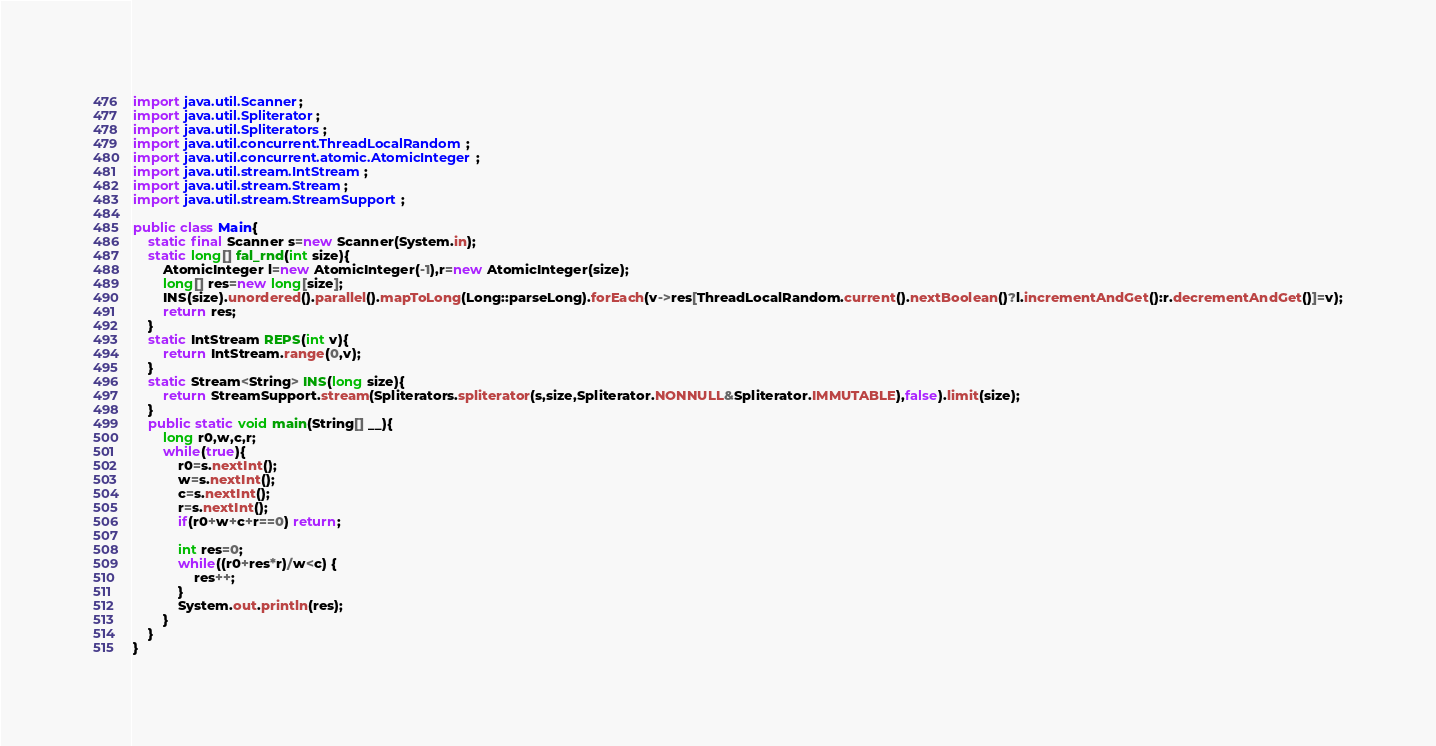Convert code to text. <code><loc_0><loc_0><loc_500><loc_500><_Java_>import java.util.Scanner;
import java.util.Spliterator;
import java.util.Spliterators;
import java.util.concurrent.ThreadLocalRandom;
import java.util.concurrent.atomic.AtomicInteger;
import java.util.stream.IntStream;
import java.util.stream.Stream;
import java.util.stream.StreamSupport;

public class Main{
	static final Scanner s=new Scanner(System.in);
	static long[] fal_rnd(int size){
		AtomicInteger l=new AtomicInteger(-1),r=new AtomicInteger(size);
		long[] res=new long[size];
		INS(size).unordered().parallel().mapToLong(Long::parseLong).forEach(v->res[ThreadLocalRandom.current().nextBoolean()?l.incrementAndGet():r.decrementAndGet()]=v);
		return res;
	}
	static IntStream REPS(int v){
		return IntStream.range(0,v);
	}
	static Stream<String> INS(long size){
		return StreamSupport.stream(Spliterators.spliterator(s,size,Spliterator.NONNULL&Spliterator.IMMUTABLE),false).limit(size);
	}
	public static void main(String[] __){
		long r0,w,c,r;
		while(true){
			r0=s.nextInt();
			w=s.nextInt();
			c=s.nextInt();
			r=s.nextInt();
			if(r0+w+c+r==0) return;
			
			int res=0;
			while((r0+res*r)/w<c) {
				res++;
			}
			System.out.println(res);
		}
	}
}</code> 